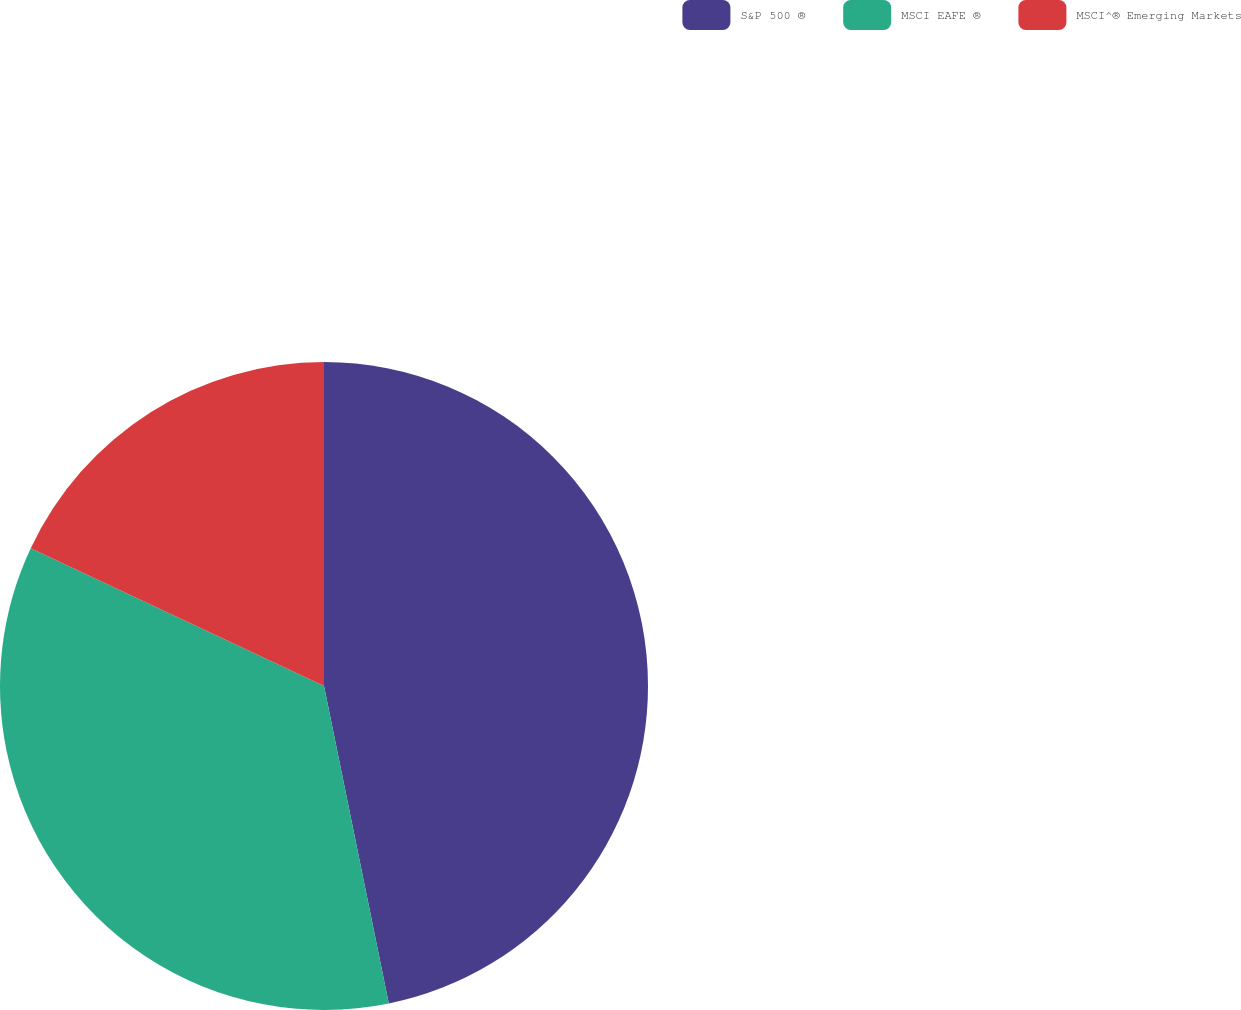<chart> <loc_0><loc_0><loc_500><loc_500><pie_chart><fcel>S&P 500 ®<fcel>MSCI EAFE ®<fcel>MSCI^® Emerging Markets<nl><fcel>46.79%<fcel>35.19%<fcel>18.01%<nl></chart> 